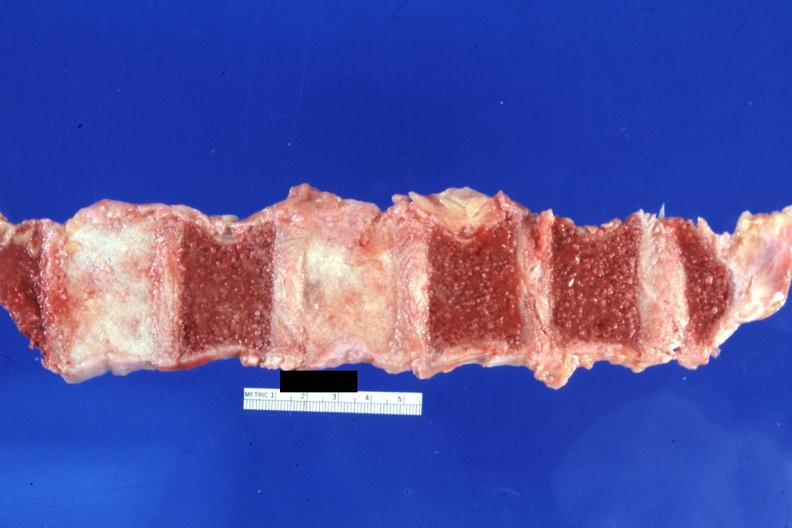what does this image show?
Answer the question using a single word or phrase. Cut surface typical ivory vertebra do not have history at time diagnosis assumed 